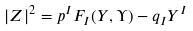<formula> <loc_0><loc_0><loc_500><loc_500>| Z | ^ { 2 } = p ^ { I } F _ { I } ( Y , \Upsilon ) - q _ { I } Y ^ { I }</formula> 